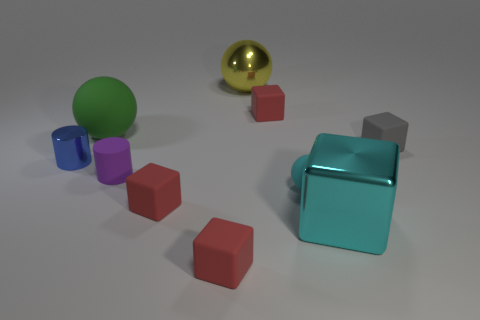Subtract all cyan balls. How many balls are left? 2 Subtract all red cylinders. How many red blocks are left? 3 Subtract all gray blocks. How many blocks are left? 4 Subtract all balls. How many objects are left? 7 Subtract all brown balls. Subtract all brown cylinders. How many balls are left? 3 Subtract 0 blue balls. How many objects are left? 10 Subtract all blue cylinders. Subtract all tiny red rubber things. How many objects are left? 6 Add 4 tiny cyan objects. How many tiny cyan objects are left? 5 Add 5 tiny cyan things. How many tiny cyan things exist? 6 